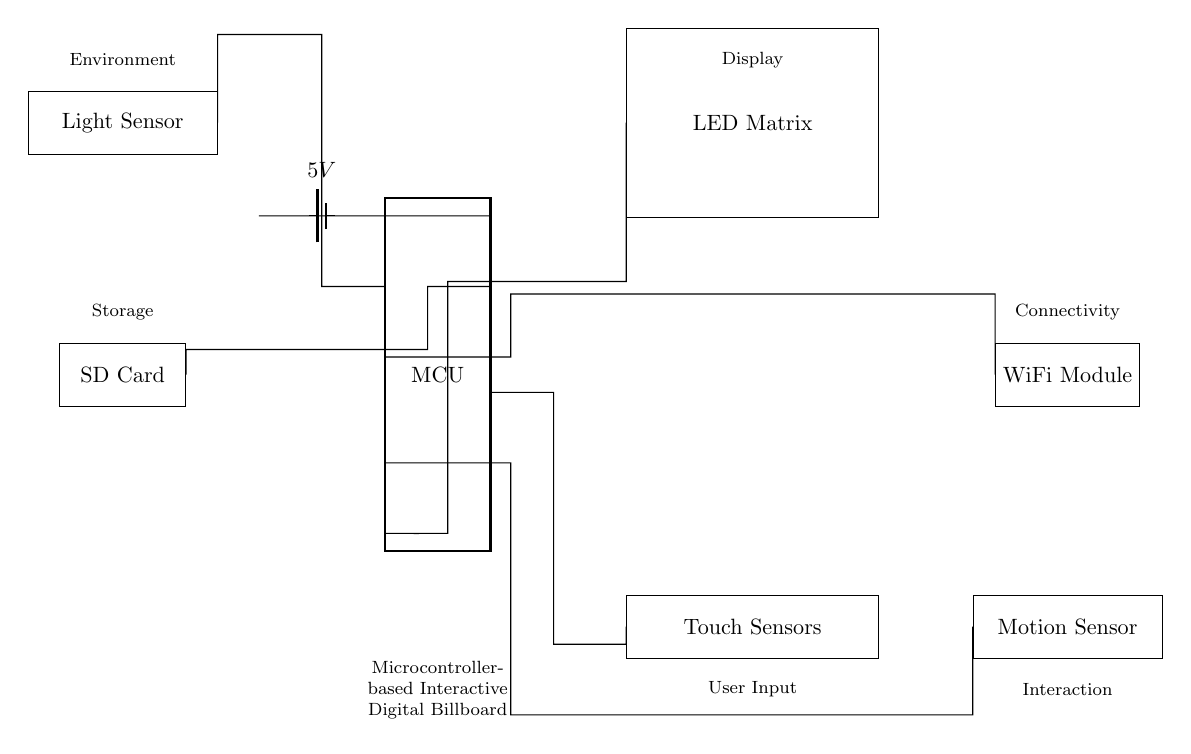What is the main component in this circuit? The main component of the circuit is the microcontroller, which manages all functionalities and connections. It is prominently labeled as "MCU" in the circuit diagram.
Answer: MCU What is the voltage supplied to the microcontroller? The circuit uses a battery labeled as "5V" that connects to the microcontroller. This is the necessary voltage required for its operation.
Answer: 5V How many touch sensors are connected to the microcontroller? The circuit diagram indicates one rectangular block labeled "Touch Sensors," which implies there is a single module that contains multiple sensors.
Answer: One What does the motion sensor do in this circuit? The motion sensor module detects movement. This provides interaction capabilities for the digital billboard, allowing it to respond to nearby activity.
Answer: Detects movement Which component communicates wirelessly? The circuit has a block labeled "WiFi Module," which indicates that this component is responsible for wireless communication with other devices or networks.
Answer: WiFi Module What is the purpose of the ambient light sensor? The ambient light sensor measures the light conditions, allowing the billboard to adjust its display brightness based on the surrounding environment for better visibility and energy efficiency.
Answer: Adjust display brightness What is the function of the SD card in this circuit? The SD card provides storage for media and data that can be displayed on the digital billboard, allowing for dynamic updates and content management.
Answer: Storage for media 